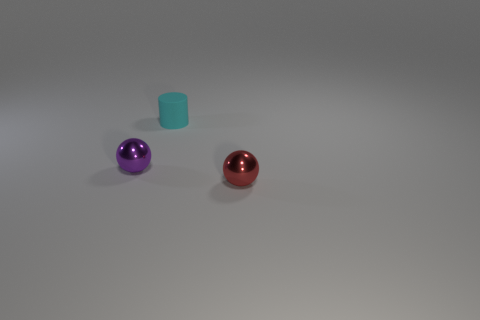What size is the metal sphere left of the metallic ball that is right of the rubber cylinder?
Give a very brief answer. Small. The purple metal ball is what size?
Your answer should be very brief. Small. There is a metal sphere on the right side of the small matte thing; does it have the same color as the tiny object behind the tiny purple metallic thing?
Provide a succinct answer. No. How many other things are there of the same material as the red object?
Provide a short and direct response. 1. Are there any metal things?
Make the answer very short. Yes. Are the small sphere on the left side of the tiny cylinder and the cyan thing made of the same material?
Give a very brief answer. No. There is another thing that is the same shape as the red metal object; what material is it?
Provide a succinct answer. Metal. Are there fewer tiny cyan rubber cylinders than tiny cyan balls?
Give a very brief answer. No. There is a small metallic thing that is to the right of the cyan cylinder; is its color the same as the small rubber cylinder?
Offer a very short reply. No. The small thing that is made of the same material as the tiny purple sphere is what color?
Your answer should be very brief. Red. 